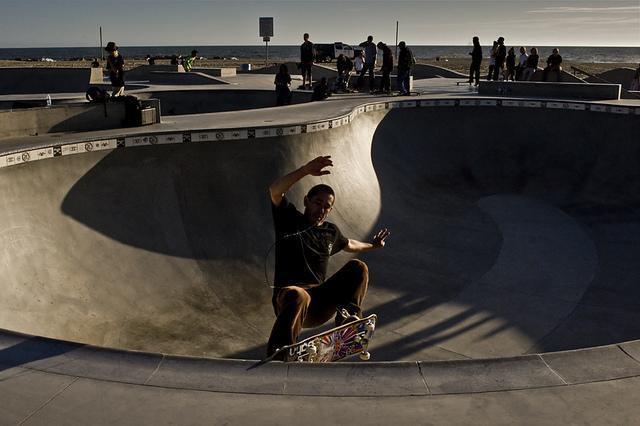How many people can be seen?
Give a very brief answer. 2. How many zebras are in the road?
Give a very brief answer. 0. 